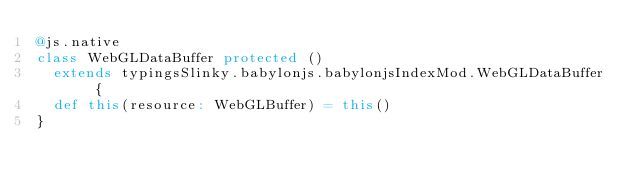<code> <loc_0><loc_0><loc_500><loc_500><_Scala_>@js.native
class WebGLDataBuffer protected ()
  extends typingsSlinky.babylonjs.babylonjsIndexMod.WebGLDataBuffer {
  def this(resource: WebGLBuffer) = this()
}
</code> 